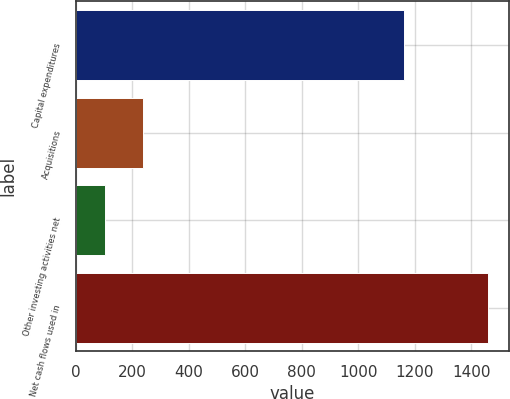Convert chart. <chart><loc_0><loc_0><loc_500><loc_500><bar_chart><fcel>Capital expenditures<fcel>Acquisitions<fcel>Other investing activities net<fcel>Net cash flows used in<nl><fcel>1160<fcel>237.7<fcel>102<fcel>1459<nl></chart> 